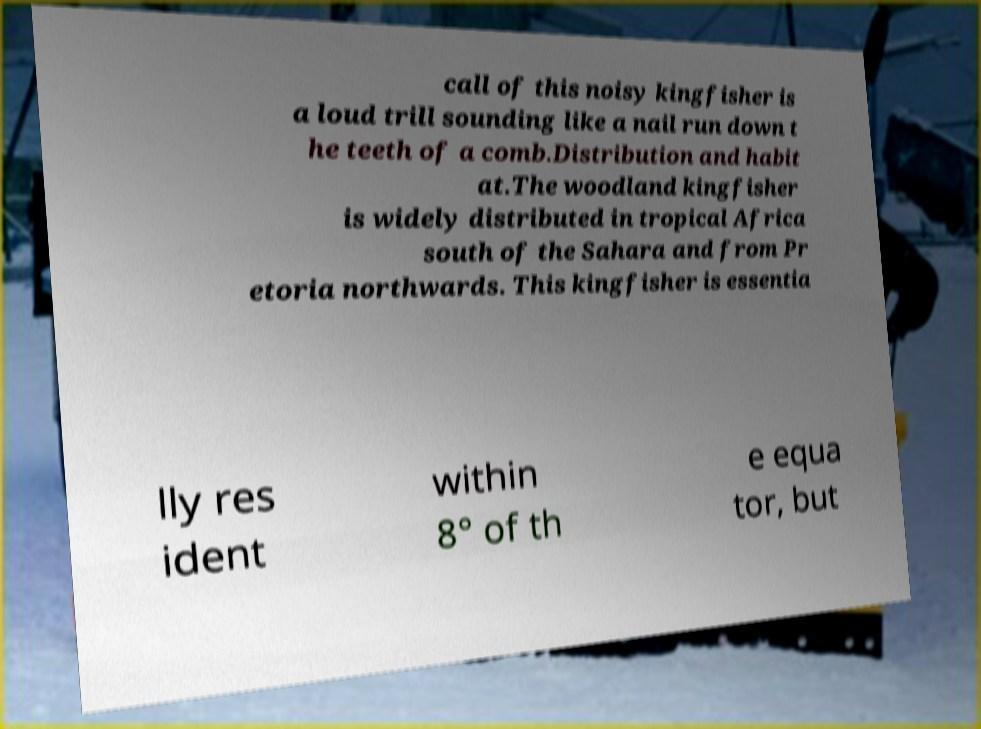Can you accurately transcribe the text from the provided image for me? call of this noisy kingfisher is a loud trill sounding like a nail run down t he teeth of a comb.Distribution and habit at.The woodland kingfisher is widely distributed in tropical Africa south of the Sahara and from Pr etoria northwards. This kingfisher is essentia lly res ident within 8° of th e equa tor, but 